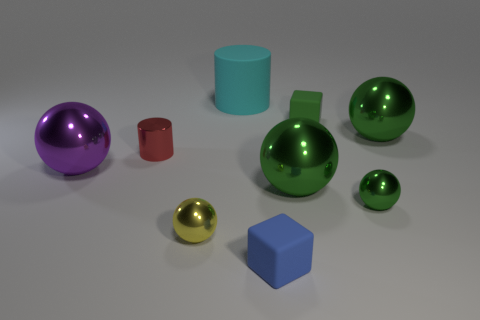How many other things are there of the same shape as the red thing?
Keep it short and to the point. 1. There is a green metal ball behind the purple object; does it have the same size as the small green metal object?
Your answer should be very brief. No. Is the number of small cubes that are on the left side of the purple metallic sphere greater than the number of small brown shiny cylinders?
Your response must be concise. No. How many tiny blue blocks are behind the small shiny ball on the left side of the matte cylinder?
Make the answer very short. 0. Are there fewer matte cylinders that are on the right side of the cyan thing than big blue balls?
Your response must be concise. No. Are there any big objects left of the small metallic ball on the left side of the block that is behind the tiny green metal ball?
Make the answer very short. Yes. Is the material of the green cube the same as the small green sphere that is right of the tiny red metal thing?
Provide a succinct answer. No. What color is the large shiny ball to the right of the block that is behind the tiny yellow shiny ball?
Provide a short and direct response. Green. There is a cylinder behind the large ball that is behind the cylinder to the left of the large rubber cylinder; what size is it?
Your answer should be very brief. Large. Is the shape of the purple thing the same as the small metal thing to the right of the large rubber cylinder?
Offer a terse response. Yes. 